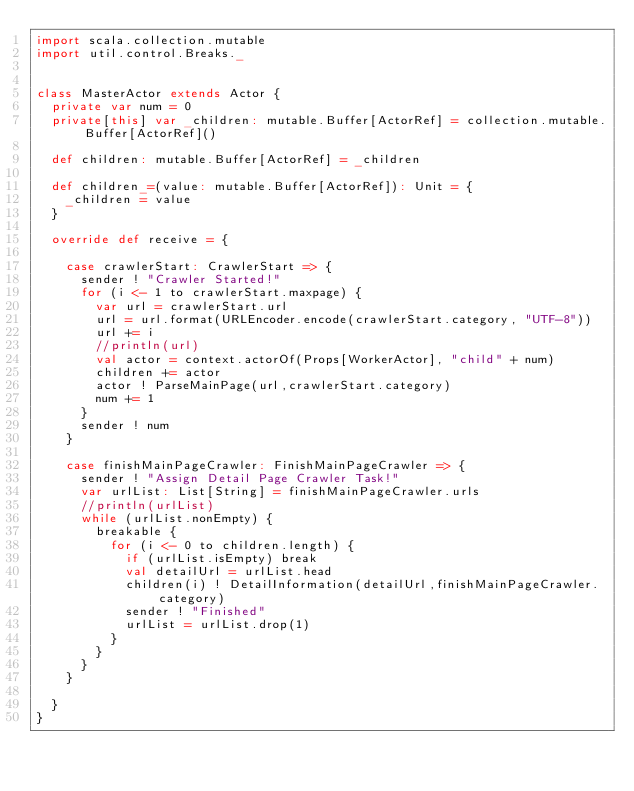<code> <loc_0><loc_0><loc_500><loc_500><_Scala_>import scala.collection.mutable
import util.control.Breaks._


class MasterActor extends Actor {
  private var num = 0
  private[this] var _children: mutable.Buffer[ActorRef] = collection.mutable.Buffer[ActorRef]()

  def children: mutable.Buffer[ActorRef] = _children

  def children_=(value: mutable.Buffer[ActorRef]): Unit = {
    _children = value
  }

  override def receive = {

    case crawlerStart: CrawlerStart => {
      sender ! "Crawler Started!"
      for (i <- 1 to crawlerStart.maxpage) {
        var url = crawlerStart.url
        url = url.format(URLEncoder.encode(crawlerStart.category, "UTF-8"))
        url += i
        //println(url)
        val actor = context.actorOf(Props[WorkerActor], "child" + num)
        children += actor
        actor ! ParseMainPage(url,crawlerStart.category)
        num += 1
      }
      sender ! num
    }

    case finishMainPageCrawler: FinishMainPageCrawler => {
      sender ! "Assign Detail Page Crawler Task!"
      var urlList: List[String] = finishMainPageCrawler.urls
      //println(urlList)
      while (urlList.nonEmpty) {
        breakable {
          for (i <- 0 to children.length) {
            if (urlList.isEmpty) break
            val detailUrl = urlList.head
            children(i) ! DetailInformation(detailUrl,finishMainPageCrawler.category)
            sender ! "Finished"
            urlList = urlList.drop(1)
          }
        }
      }
    }

  }
}</code> 